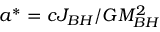<formula> <loc_0><loc_0><loc_500><loc_500>a ^ { * } = c J _ { B H } / G M _ { B H } ^ { 2 }</formula> 